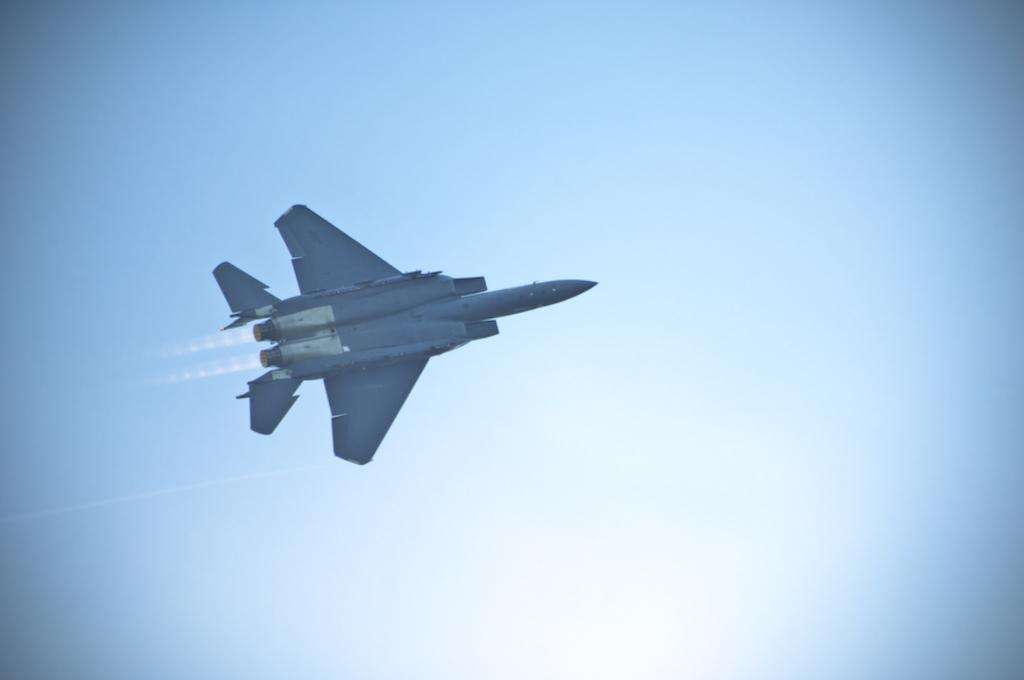What is the main subject of the image? The main subject of the image is an aircraft. Where is the aircraft located in the image? The aircraft is in the center of the image. What can be seen in the background of the image? The sky is visible in the background of the image. How many babies are visible in the image? There are no babies present in the image; it features an aircraft and the sky. What type of income is generated by the aircraft in the image? The image does not provide information about the income generated by the aircraft. 